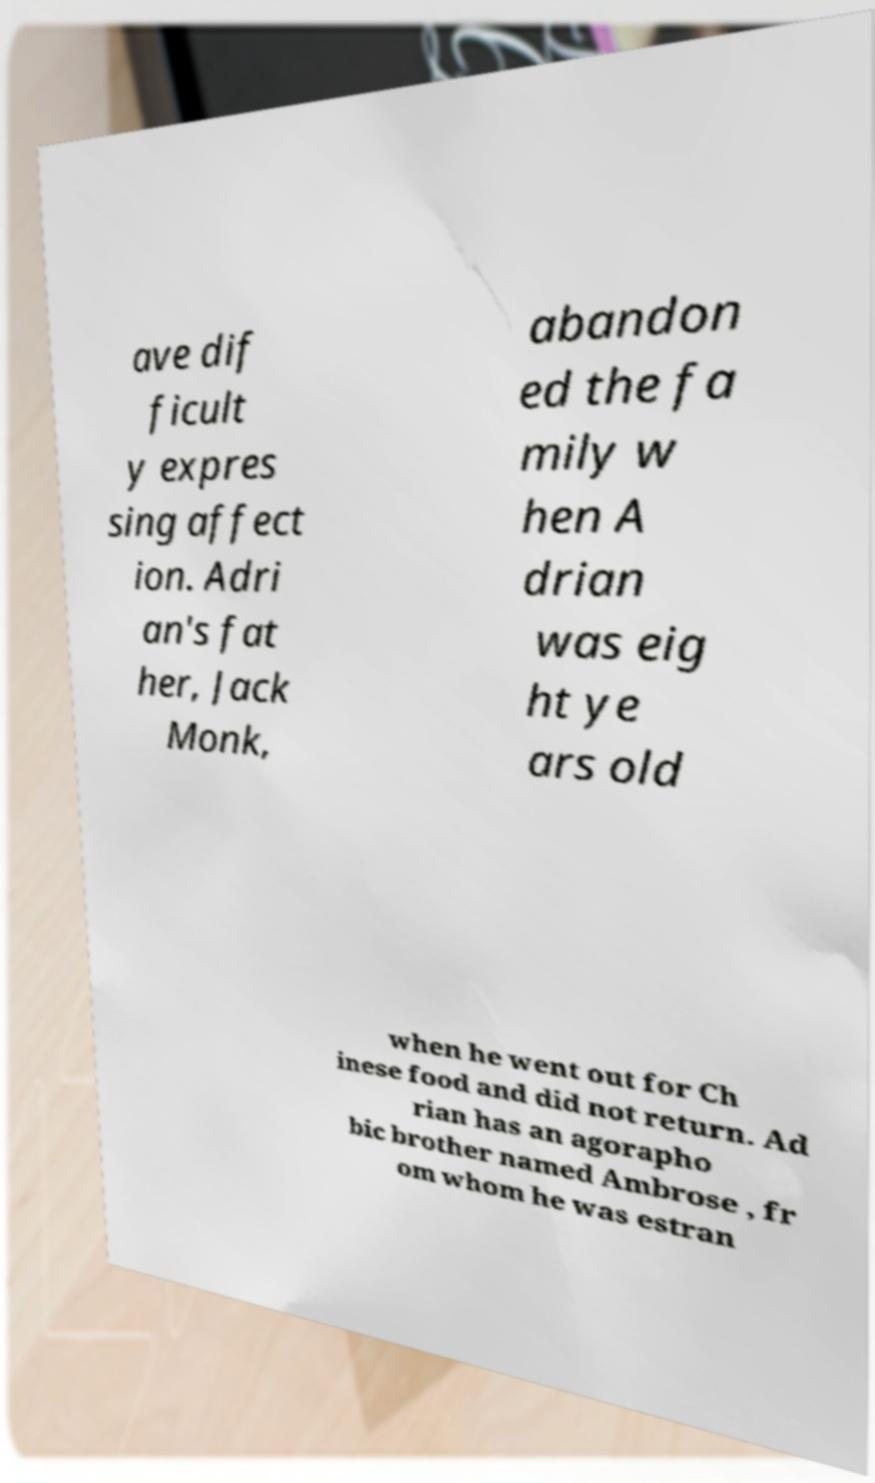Please identify and transcribe the text found in this image. ave dif ficult y expres sing affect ion. Adri an's fat her, Jack Monk, abandon ed the fa mily w hen A drian was eig ht ye ars old when he went out for Ch inese food and did not return. Ad rian has an agorapho bic brother named Ambrose , fr om whom he was estran 